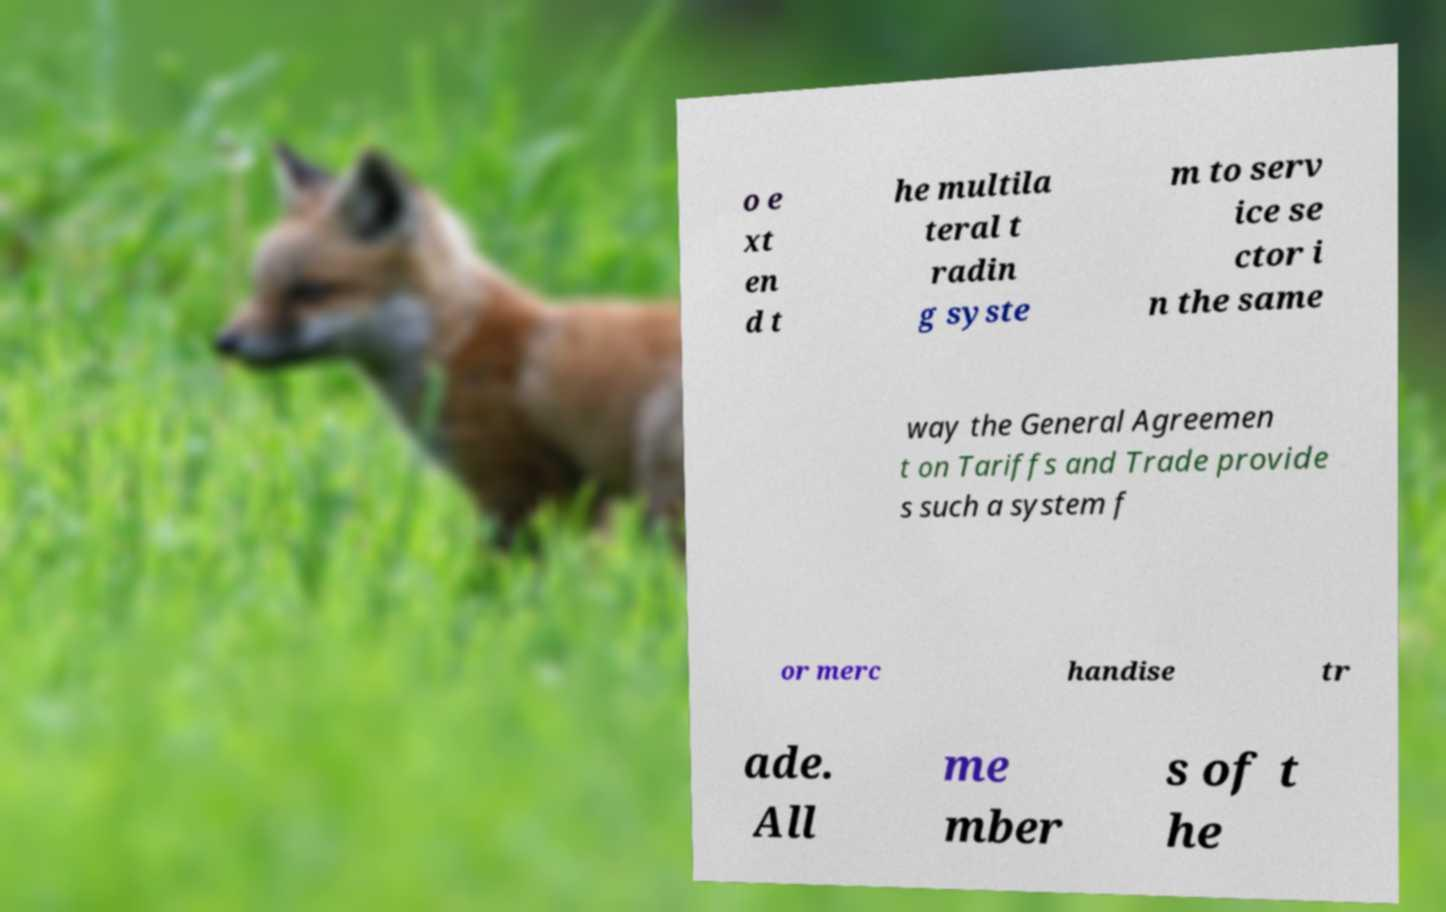Can you accurately transcribe the text from the provided image for me? o e xt en d t he multila teral t radin g syste m to serv ice se ctor i n the same way the General Agreemen t on Tariffs and Trade provide s such a system f or merc handise tr ade. All me mber s of t he 